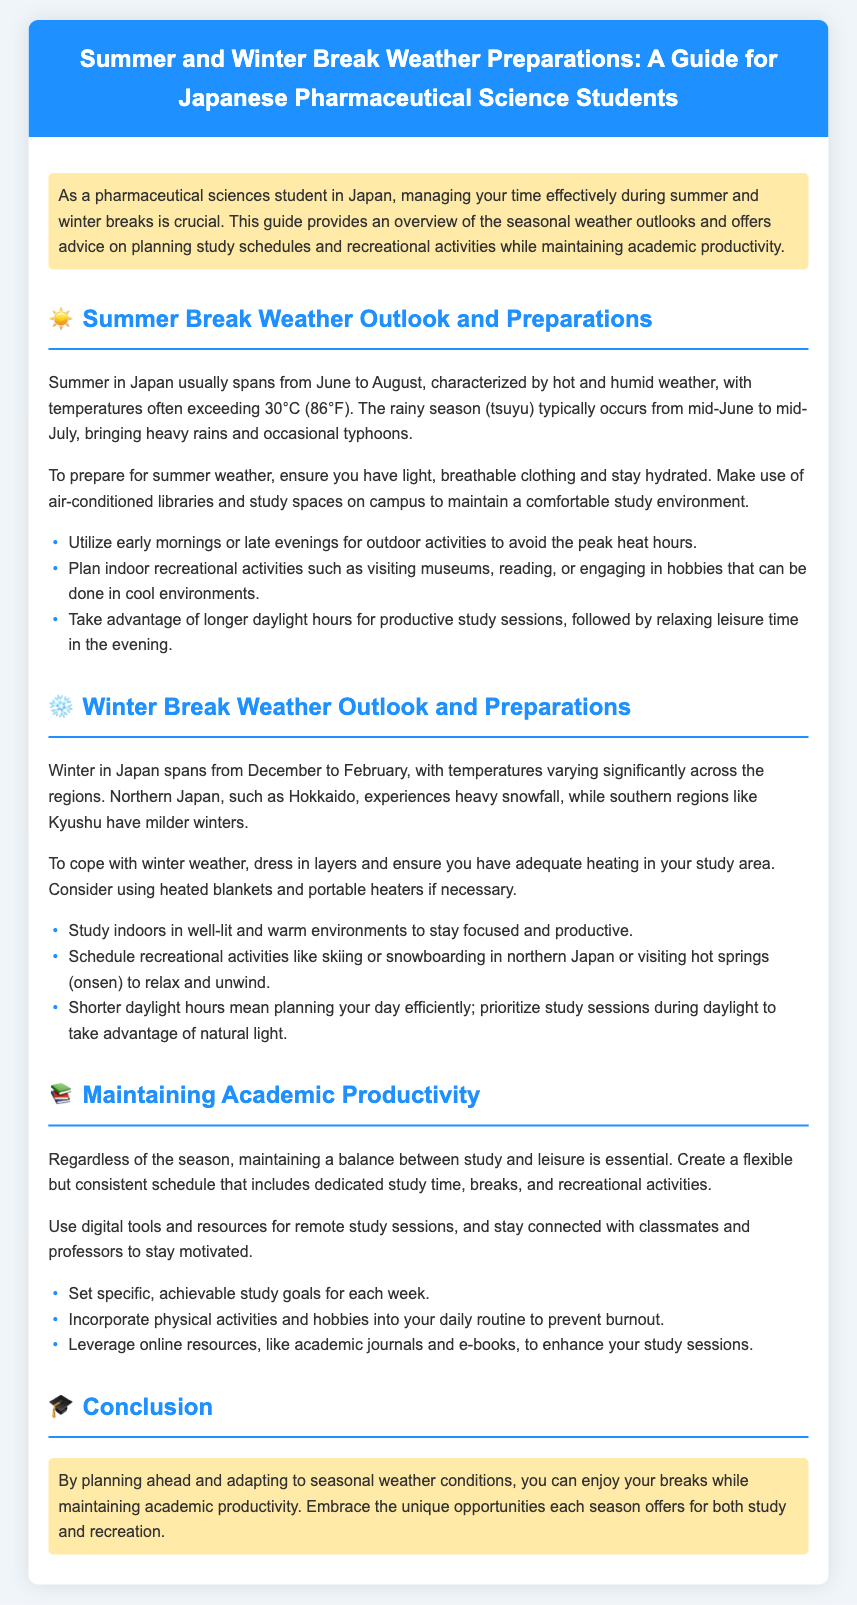What months does summer in Japan typically span? The document states that summer in Japan usually spans from June to August.
Answer: June to August What are common summer outdoor activities to avoid the peak heat hours? The document mentions utilizing early mornings or late evenings for outdoor activities.
Answer: Early mornings or late evenings How should students dress to cope with winter weather? The document advises dressing in layers to cope with winter weather.
Answer: In layers What is a notable recreational activity mentioned for winter in northern Japan? The document highlights skiing or snowboarding in northern Japan as a recreational activity.
Answer: Skiing or snowboarding What is a recommendation for studying indoors during winter? The document suggests studying indoors in well-lit and warm environments.
Answer: Well-lit and warm environments What is a key factor for maintaining academic productivity regardless of the season? The document emphasizes maintaining a balance between study and leisure.
Answer: Balance between study and leisure How long is the rainy season (tsuyu) in summer? The rainy season (tsuyu) occurs from mid-June to mid-July, which is about one month.
Answer: About one month What is the purpose of the highlighted section at the beginning of the document? The highlighted section provides an overview of the guide's focus on managing time effectively.
Answer: Overview of managing time effectively 